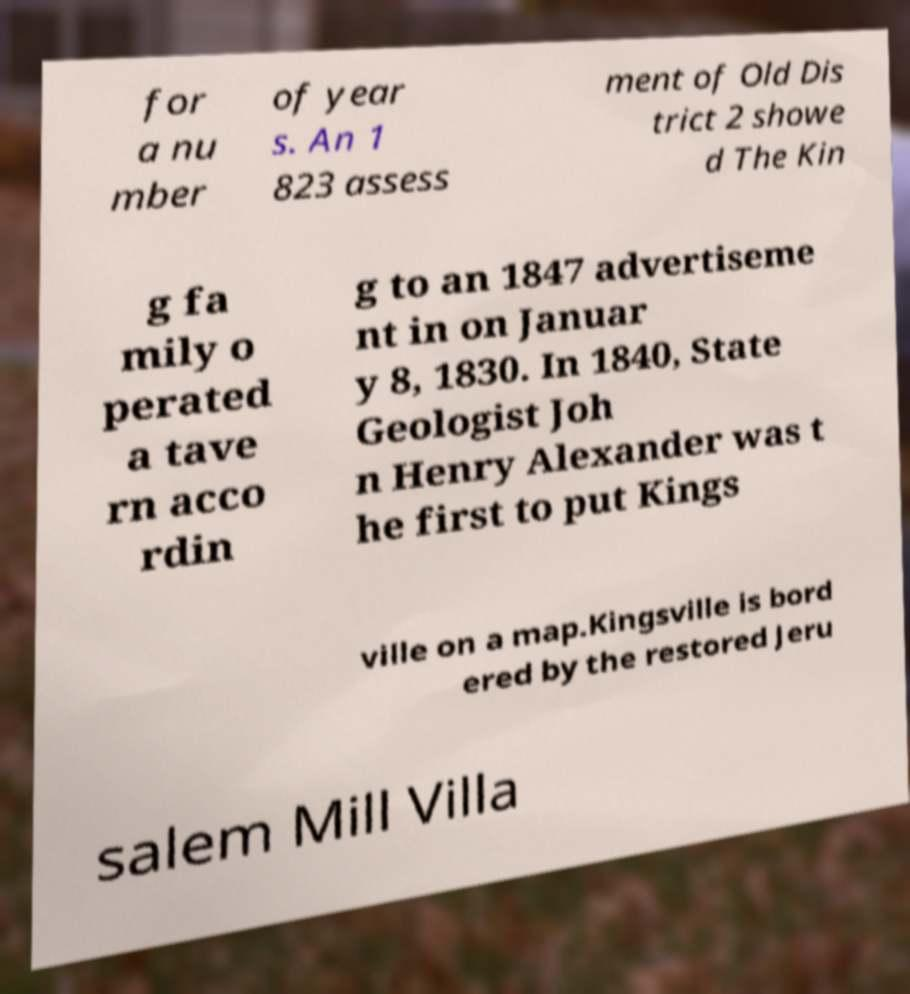Please identify and transcribe the text found in this image. for a nu mber of year s. An 1 823 assess ment of Old Dis trict 2 showe d The Kin g fa mily o perated a tave rn acco rdin g to an 1847 advertiseme nt in on Januar y 8, 1830. In 1840, State Geologist Joh n Henry Alexander was t he first to put Kings ville on a map.Kingsville is bord ered by the restored Jeru salem Mill Villa 